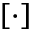<formula> <loc_0><loc_0><loc_500><loc_500>[ \cdot ]</formula> 